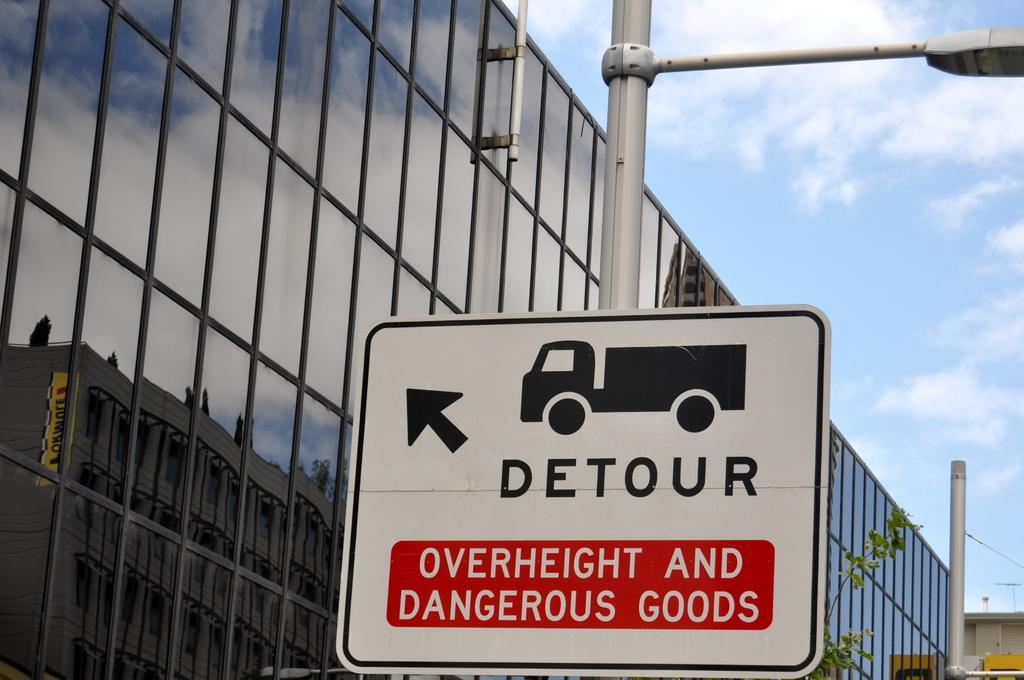<image>
Describe the image concisely. A detour sign with a picture of a truck warns of dangerous goods. 